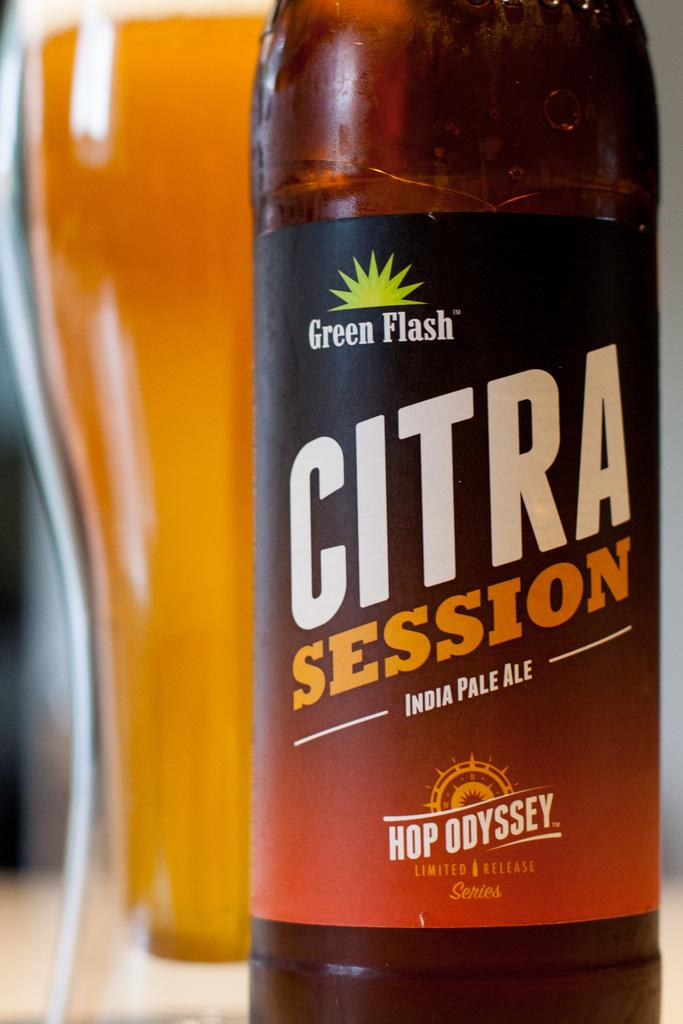<image>
Provide a brief description of the given image. Large Citra Session beer bottle next to a cup of beer. 